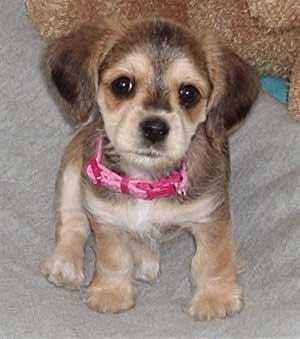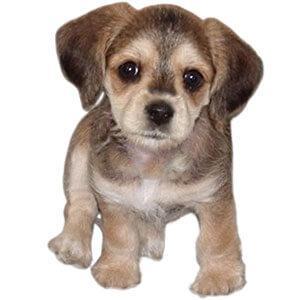The first image is the image on the left, the second image is the image on the right. Considering the images on both sides, is "In at least one of the photos, a dog's body is facing left." valid? Answer yes or no. No. The first image is the image on the left, the second image is the image on the right. Evaluate the accuracy of this statement regarding the images: "In one of the images, a dog can be seen wearing a collar.". Is it true? Answer yes or no. Yes. 